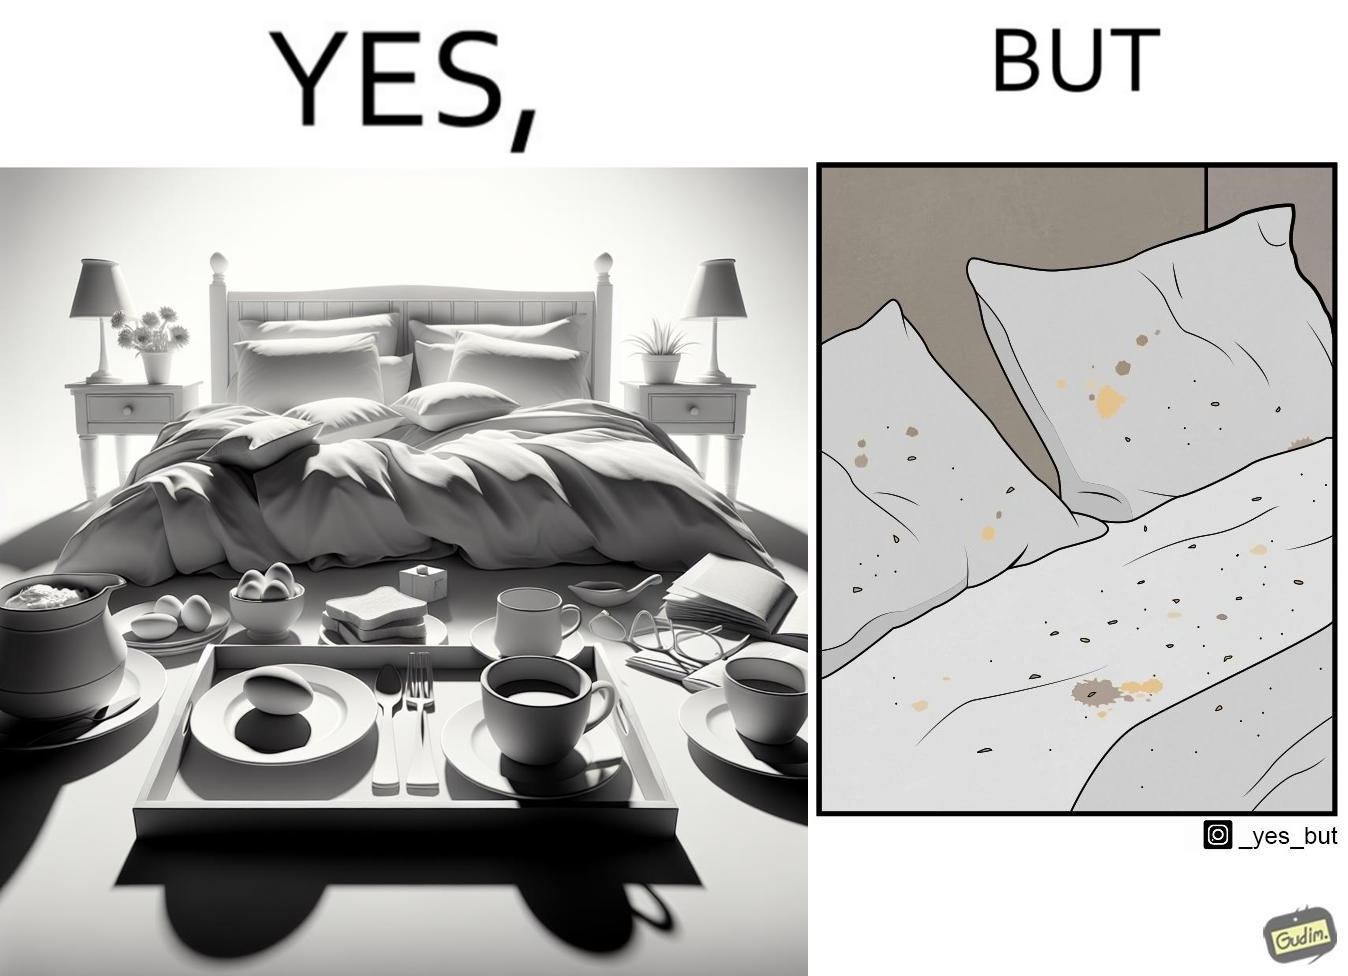Describe the contrast between the left and right parts of this image. In the left part of the image: Breakfast on bed In the right part of the image: Food crumbs on bed 